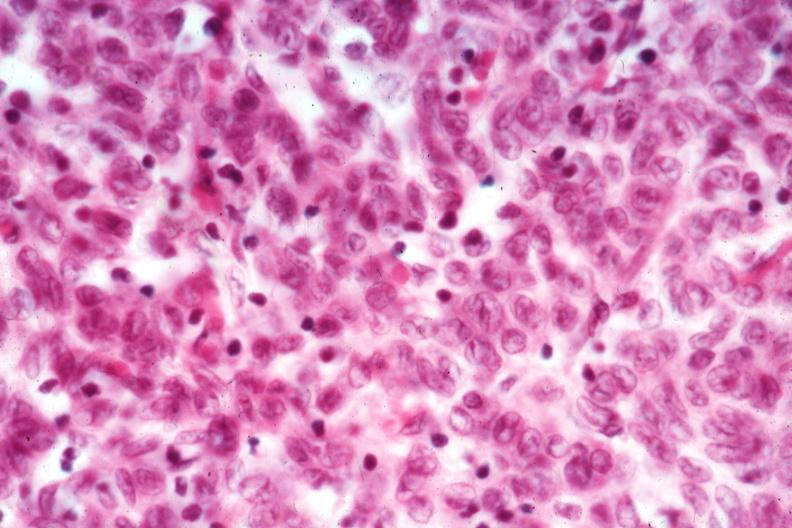s stein leventhal present?
Answer the question using a single word or phrase. No 